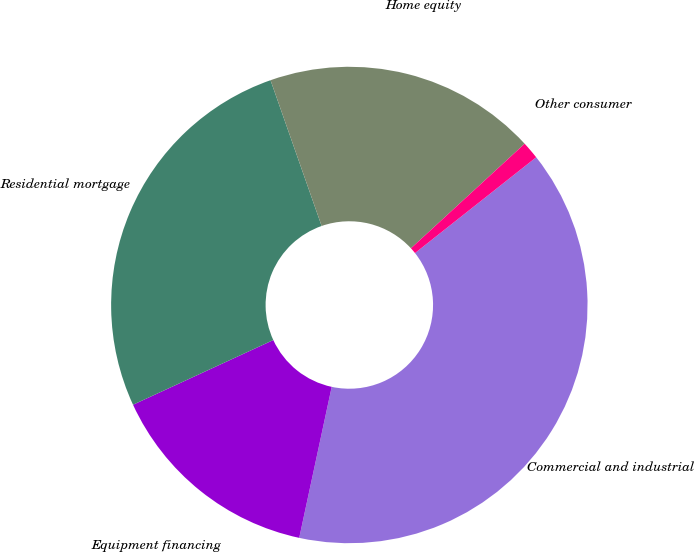Convert chart to OTSL. <chart><loc_0><loc_0><loc_500><loc_500><pie_chart><fcel>Commercial and industrial<fcel>Equipment financing<fcel>Residential mortgage<fcel>Home equity<fcel>Other consumer<nl><fcel>39.02%<fcel>14.75%<fcel>26.51%<fcel>18.53%<fcel>1.19%<nl></chart> 